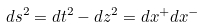<formula> <loc_0><loc_0><loc_500><loc_500>d s ^ { 2 } = d t ^ { 2 } - d z ^ { 2 } = d x ^ { + } d x ^ { - }</formula> 